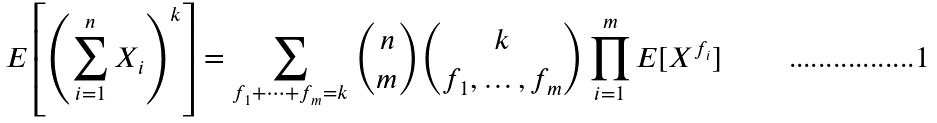<formula> <loc_0><loc_0><loc_500><loc_500>E \left [ \left ( \sum _ { i = 1 } ^ { n } X _ { i } \right ) ^ { k } \right ] = \sum _ { f _ { 1 } + \dots + f _ { m } = k } { n \choose m } { k \choose f _ { 1 } , \dots , f _ { m } } \prod _ { i = 1 } ^ { m } E [ X ^ { f _ { i } } ]</formula> 